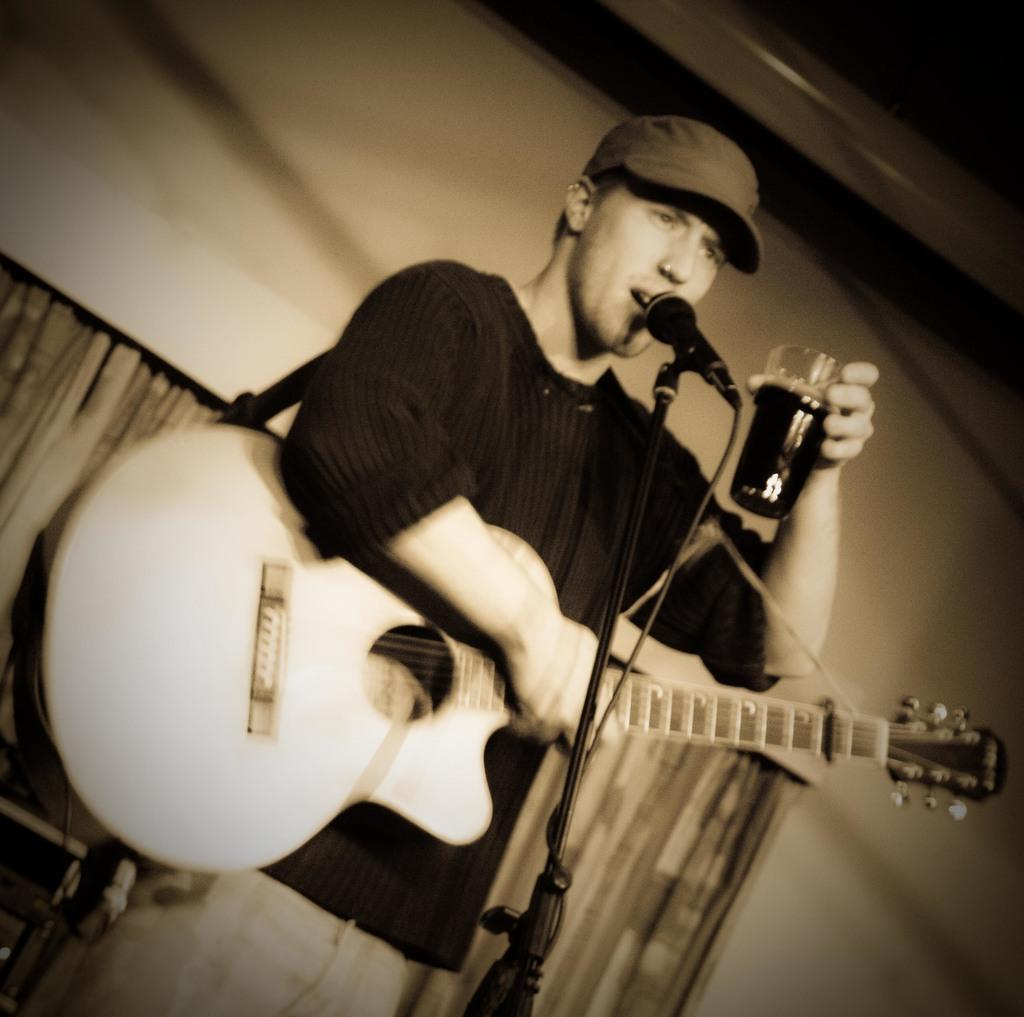What is the man in the image holding? The man is holding a guitar and a glass. What object is associated with the man's profession or activity in the image? The man is holding a guitar, which is commonly associated with musicians. What is the purpose of the microphone in the image? The microphone is likely used for amplifying the man's voice or the sound of his guitar. What can be seen in the background of the image? There is a curtain in the background of the image. Can you see the man's aunt holding a pen in the image? There is no aunt or pen present in the image. What type of snake can be seen slithering across the stage in the image? There is no snake present in the image. 